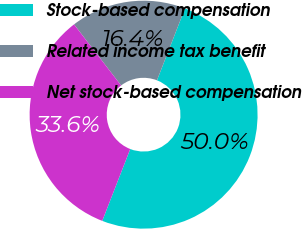Convert chart to OTSL. <chart><loc_0><loc_0><loc_500><loc_500><pie_chart><fcel>Stock-based compensation<fcel>Related income tax benefit<fcel>Net stock-based compensation<nl><fcel>50.0%<fcel>16.36%<fcel>33.64%<nl></chart> 